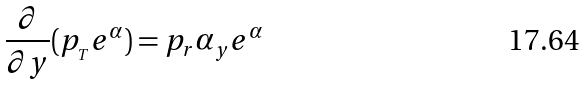<formula> <loc_0><loc_0><loc_500><loc_500>\frac { \partial } { \partial y } ( p _ { _ { T } } e ^ { \alpha } ) = p _ { r } \alpha _ { y } e ^ { \alpha }</formula> 